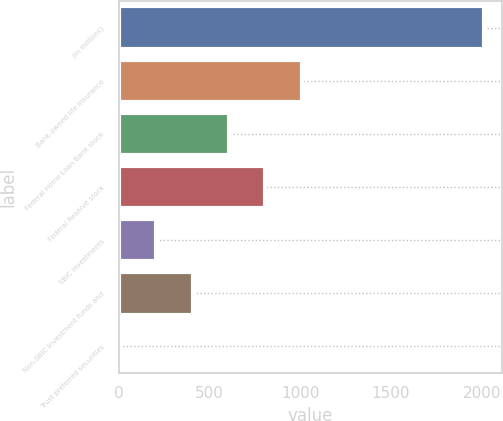Convert chart to OTSL. <chart><loc_0><loc_0><loc_500><loc_500><bar_chart><fcel>(In millions)<fcel>Bank-owned life insurance<fcel>Federal Home Loan Bank stock<fcel>Federal Reserve stock<fcel>SBIC investments<fcel>Non-SBIC investment funds and<fcel>Trust preferred securities<nl><fcel>2013<fcel>1009<fcel>607.4<fcel>808.2<fcel>205.8<fcel>406.6<fcel>5<nl></chart> 